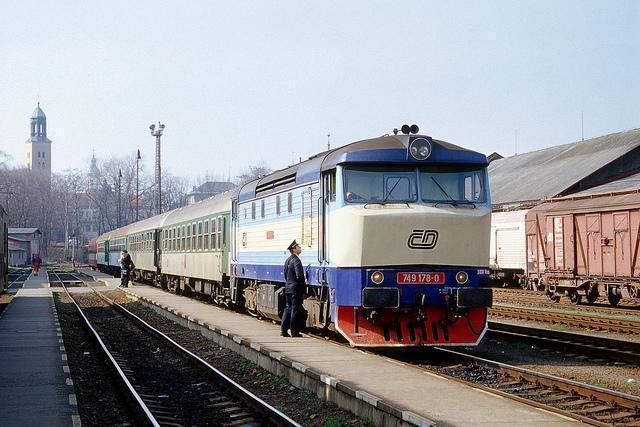What does this vehicle travel on?
Answer the question by selecting the correct answer among the 4 following choices and explain your choice with a short sentence. The answer should be formatted with the following format: `Answer: choice
Rationale: rationale.`
Options: Water, rails, air currents, roadways. Answer: rails.
Rationale: It travels on the rails. 